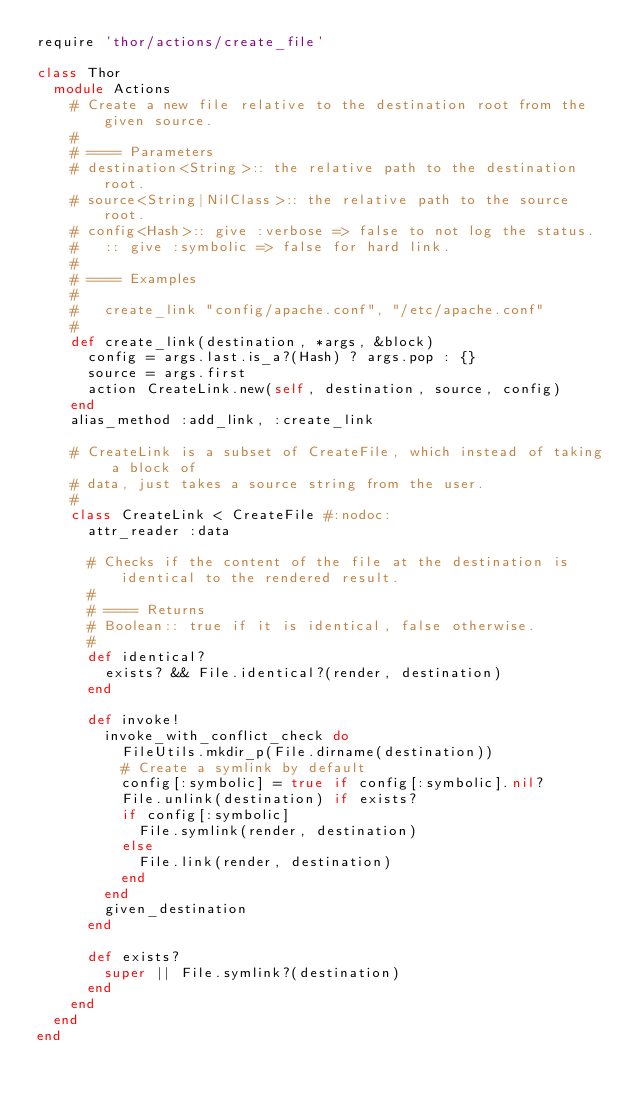Convert code to text. <code><loc_0><loc_0><loc_500><loc_500><_Ruby_>require 'thor/actions/create_file'

class Thor
  module Actions
    # Create a new file relative to the destination root from the given source.
    #
    # ==== Parameters
    # destination<String>:: the relative path to the destination root.
    # source<String|NilClass>:: the relative path to the source root.
    # config<Hash>:: give :verbose => false to not log the status.
    #   :: give :symbolic => false for hard link.
    #
    # ==== Examples
    #
    #   create_link "config/apache.conf", "/etc/apache.conf"
    #
    def create_link(destination, *args, &block)
      config = args.last.is_a?(Hash) ? args.pop : {}
      source = args.first
      action CreateLink.new(self, destination, source, config)
    end
    alias_method :add_link, :create_link

    # CreateLink is a subset of CreateFile, which instead of taking a block of
    # data, just takes a source string from the user.
    #
    class CreateLink < CreateFile #:nodoc:
      attr_reader :data

      # Checks if the content of the file at the destination is identical to the rendered result.
      #
      # ==== Returns
      # Boolean:: true if it is identical, false otherwise.
      #
      def identical?
        exists? && File.identical?(render, destination)
      end

      def invoke!
        invoke_with_conflict_check do
          FileUtils.mkdir_p(File.dirname(destination))
          # Create a symlink by default
          config[:symbolic] = true if config[:symbolic].nil?
          File.unlink(destination) if exists?
          if config[:symbolic]
            File.symlink(render, destination)
          else
            File.link(render, destination)
          end
        end
        given_destination
      end

      def exists?
        super || File.symlink?(destination)
      end
    end
  end
end
</code> 